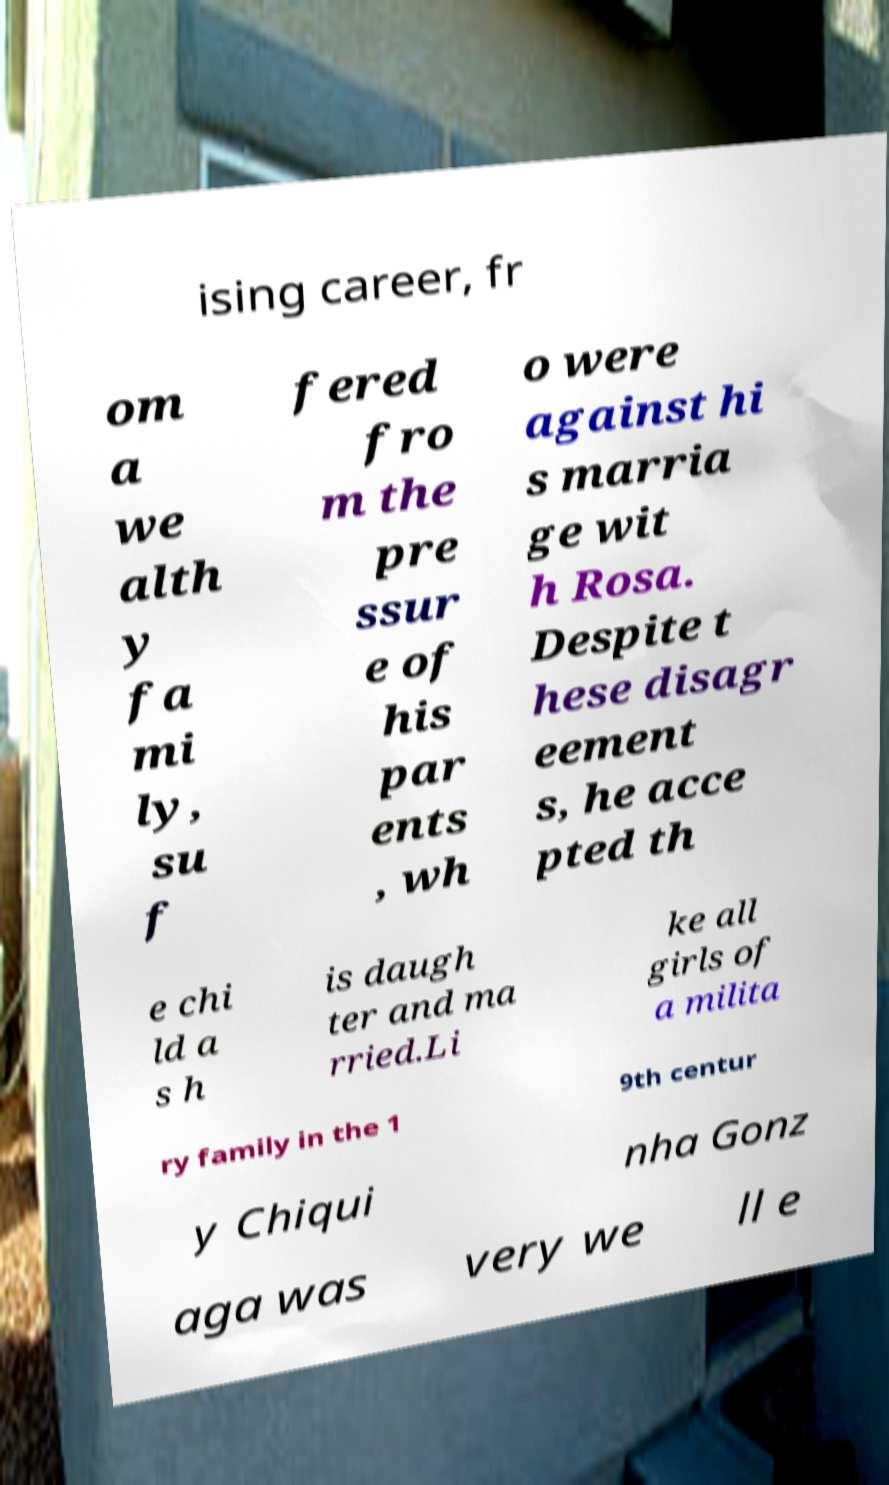Could you extract and type out the text from this image? ising career, fr om a we alth y fa mi ly, su f fered fro m the pre ssur e of his par ents , wh o were against hi s marria ge wit h Rosa. Despite t hese disagr eement s, he acce pted th e chi ld a s h is daugh ter and ma rried.Li ke all girls of a milita ry family in the 1 9th centur y Chiqui nha Gonz aga was very we ll e 